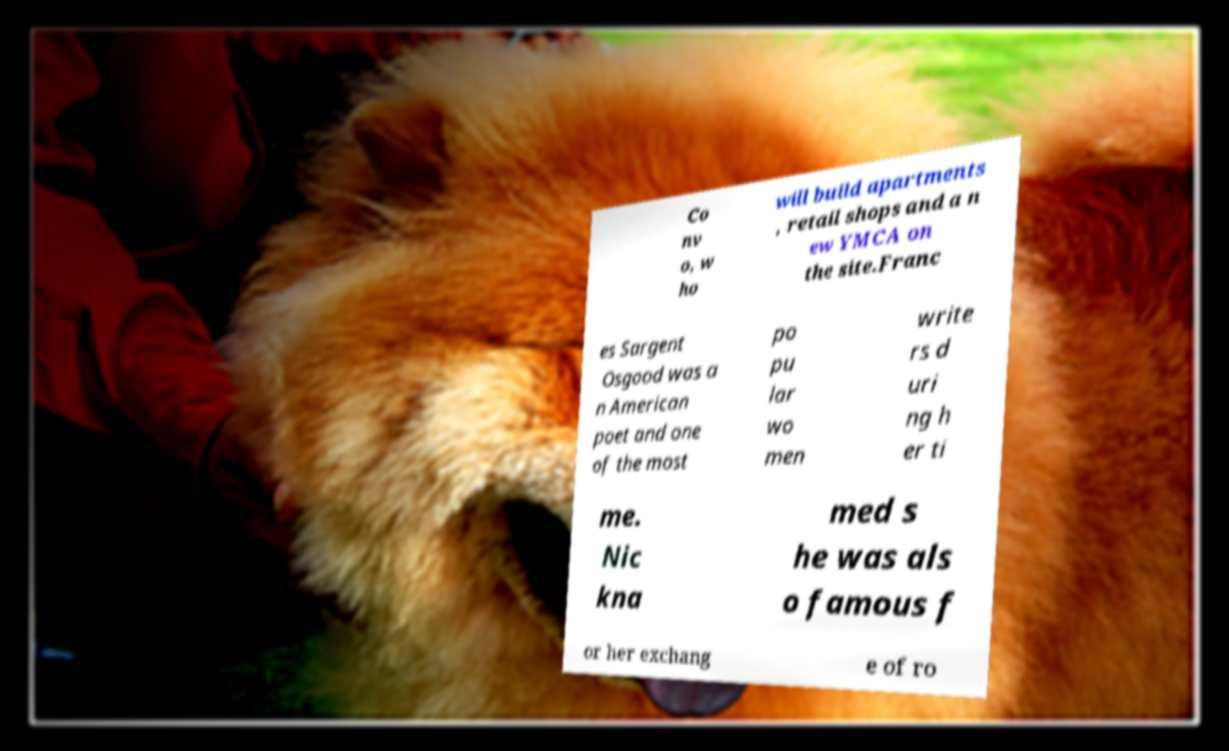Please read and relay the text visible in this image. What does it say? Co nv o, w ho will build apartments , retail shops and a n ew YMCA on the site.Franc es Sargent Osgood was a n American poet and one of the most po pu lar wo men write rs d uri ng h er ti me. Nic kna med s he was als o famous f or her exchang e of ro 